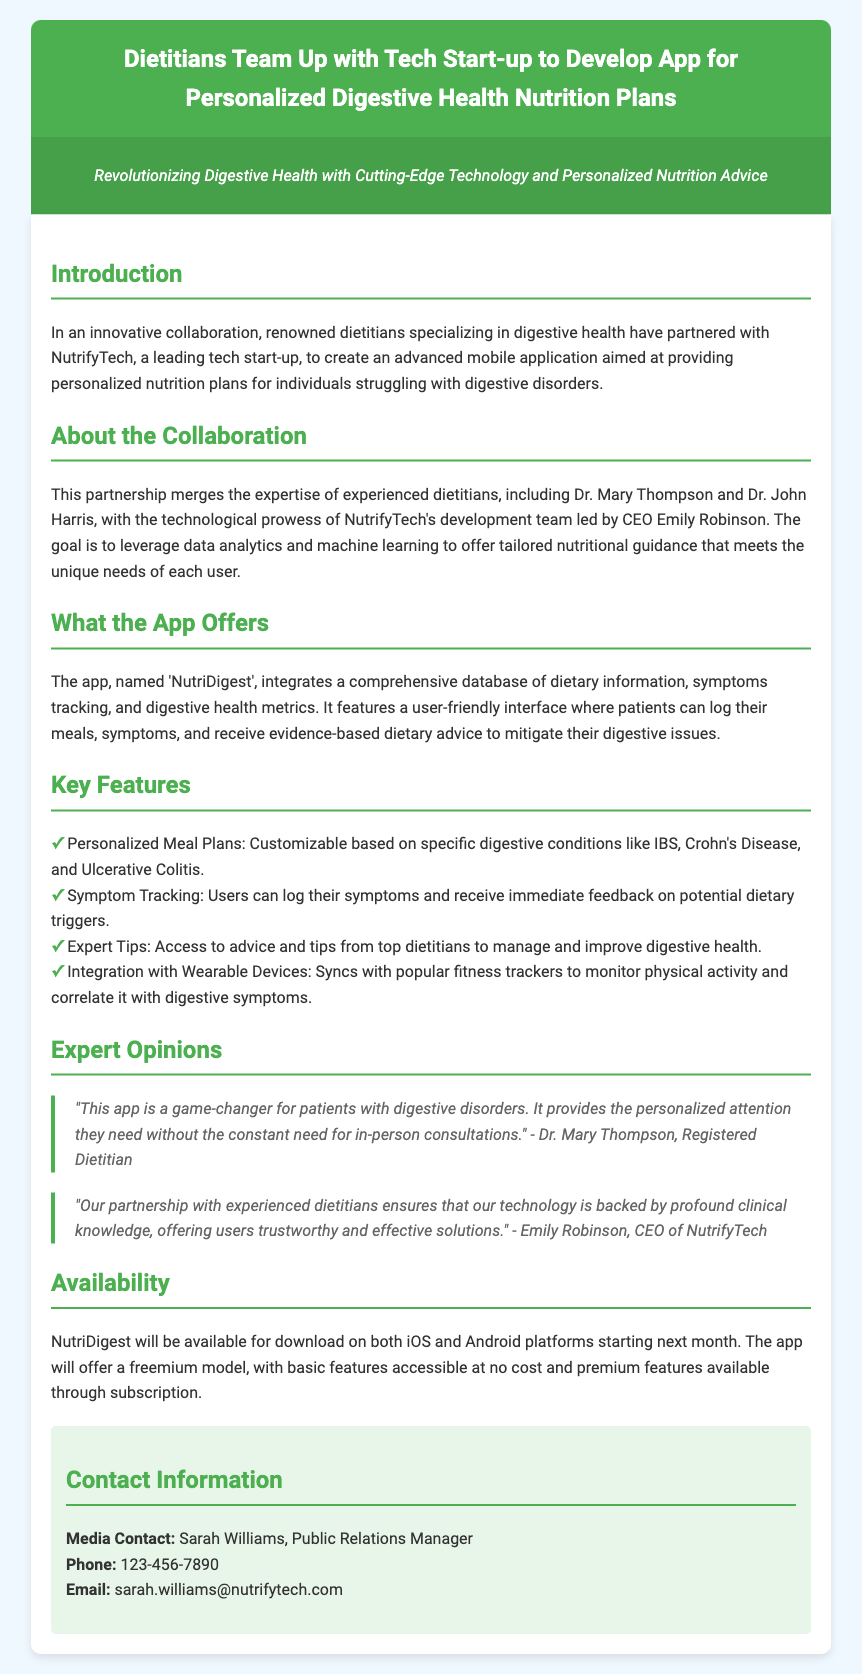What is the name of the app being developed? The app being developed is referred to as 'NutriDigest'.
Answer: NutriDigest Who are the two dietitians mentioned in the collaboration? The two dietitians mentioned are Dr. Mary Thompson and Dr. John Harris.
Answer: Dr. Mary Thompson and Dr. John Harris What is the primary goal of the app? The primary goal of the app is to provide personalized nutrition plans for individuals struggling with digestive disorders.
Answer: Personalized nutrition plans Which company is partnering with the dietitians? The dietitians are partnering with NutrifyTech.
Answer: NutrifyTech What kind of model will the app use for its features? The app will offer a freemium model for its features.
Answer: Freemium model What platforms will NutriDigest be available on? NutriDigest will be available on both iOS and Android platforms.
Answer: iOS and Android What unique feature allows users to monitor physical activity? The app has integration with wearable devices for monitoring physical activity.
Answer: Integration with wearable devices What is Dr. Mary Thompson's title? Dr. Mary Thompson holds the title of Registered Dietitian.
Answer: Registered Dietitian Who is the CEO of NutrifyTech? The CEO of NutrifyTech is Emily Robinson.
Answer: Emily Robinson 